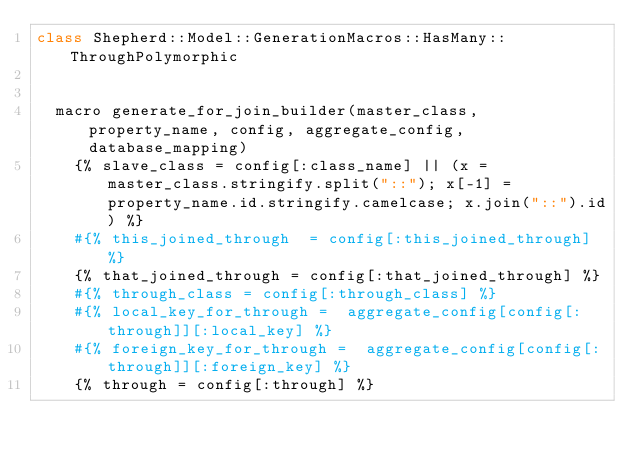<code> <loc_0><loc_0><loc_500><loc_500><_Crystal_>class Shepherd::Model::GenerationMacros::HasMany::ThroughPolymorphic


  macro generate_for_join_builder(master_class, property_name, config, aggregate_config, database_mapping)
    {% slave_class = config[:class_name] || (x = master_class.stringify.split("::"); x[-1] = property_name.id.stringify.camelcase; x.join("::").id) %}
    #{% this_joined_through  = config[:this_joined_through] %}
    {% that_joined_through = config[:that_joined_through] %}
    #{% through_class = config[:through_class] %}
    #{% local_key_for_through =  aggregate_config[config[:through]][:local_key] %}
    #{% foreign_key_for_through =  aggregate_config[config[:through]][:foreign_key] %}
    {% through = config[:through] %}</code> 